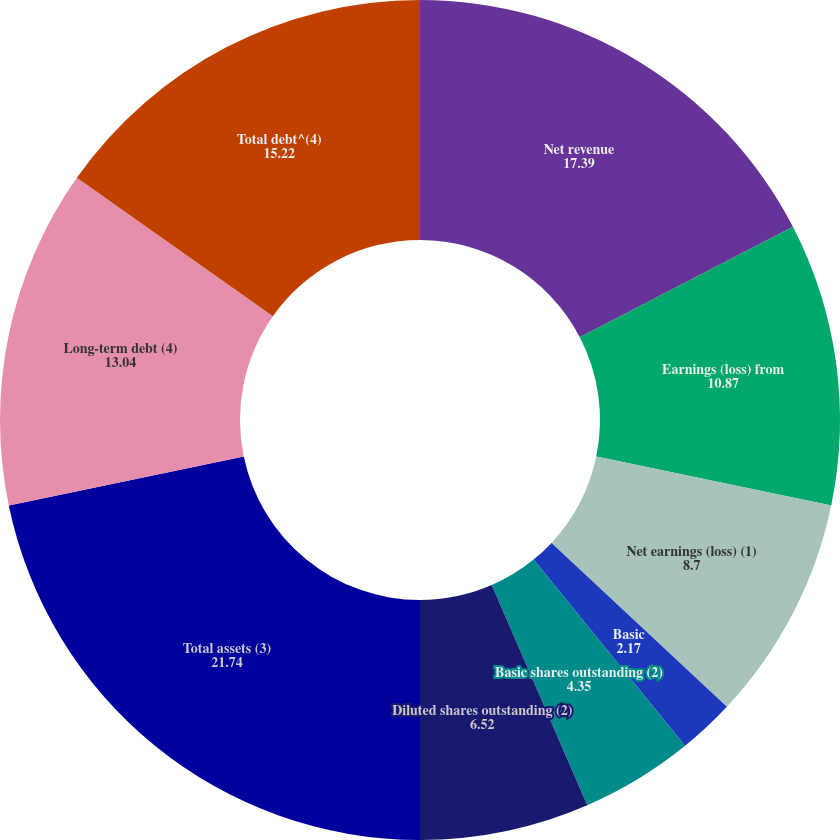Convert chart to OTSL. <chart><loc_0><loc_0><loc_500><loc_500><pie_chart><fcel>Net revenue<fcel>Earnings (loss) from<fcel>Net earnings (loss) (1)<fcel>Basic<fcel>Diluted<fcel>Basic shares outstanding (2)<fcel>Diluted shares outstanding (2)<fcel>Total assets (3)<fcel>Long-term debt (4)<fcel>Total debt^(4)<nl><fcel>17.39%<fcel>10.87%<fcel>8.7%<fcel>2.17%<fcel>0.0%<fcel>4.35%<fcel>6.52%<fcel>21.74%<fcel>13.04%<fcel>15.22%<nl></chart> 